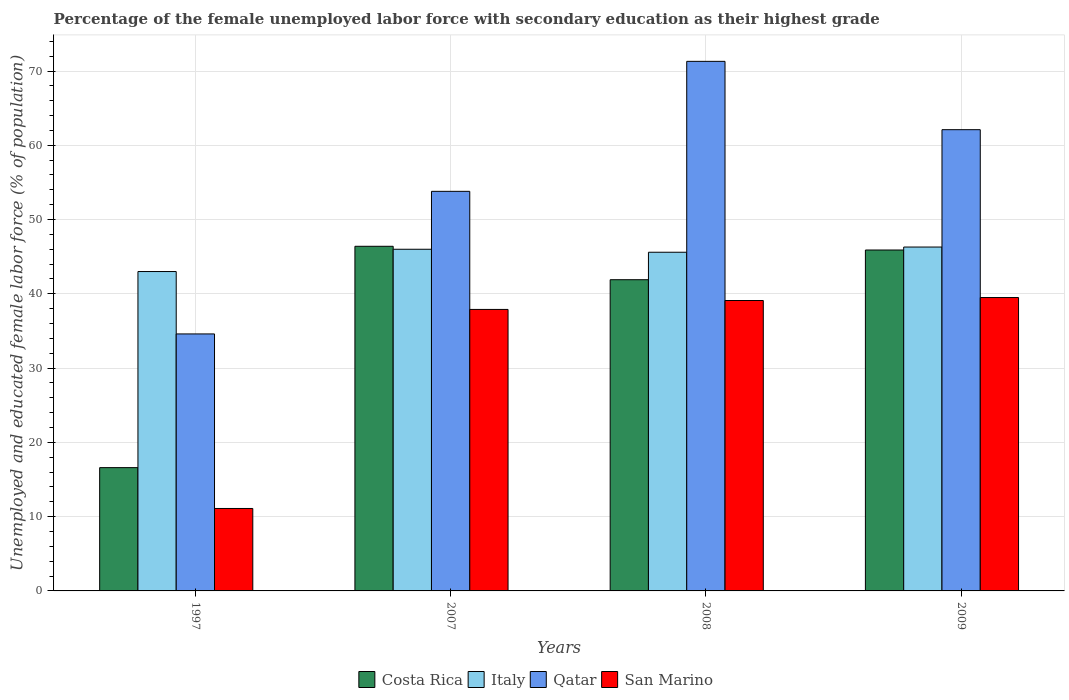How many different coloured bars are there?
Offer a terse response. 4. How many groups of bars are there?
Ensure brevity in your answer.  4. Are the number of bars per tick equal to the number of legend labels?
Offer a very short reply. Yes. How many bars are there on the 1st tick from the left?
Provide a succinct answer. 4. In how many cases, is the number of bars for a given year not equal to the number of legend labels?
Offer a very short reply. 0. What is the percentage of the unemployed female labor force with secondary education in Qatar in 2008?
Your answer should be compact. 71.3. Across all years, what is the maximum percentage of the unemployed female labor force with secondary education in San Marino?
Your answer should be compact. 39.5. Across all years, what is the minimum percentage of the unemployed female labor force with secondary education in Qatar?
Your response must be concise. 34.6. In which year was the percentage of the unemployed female labor force with secondary education in Qatar maximum?
Offer a very short reply. 2008. In which year was the percentage of the unemployed female labor force with secondary education in Italy minimum?
Your answer should be very brief. 1997. What is the total percentage of the unemployed female labor force with secondary education in Costa Rica in the graph?
Give a very brief answer. 150.8. What is the difference between the percentage of the unemployed female labor force with secondary education in Qatar in 2007 and that in 2008?
Provide a succinct answer. -17.5. What is the difference between the percentage of the unemployed female labor force with secondary education in Italy in 2008 and the percentage of the unemployed female labor force with secondary education in Costa Rica in 2009?
Make the answer very short. -0.3. What is the average percentage of the unemployed female labor force with secondary education in San Marino per year?
Keep it short and to the point. 31.9. In the year 1997, what is the difference between the percentage of the unemployed female labor force with secondary education in Italy and percentage of the unemployed female labor force with secondary education in Costa Rica?
Offer a terse response. 26.4. In how many years, is the percentage of the unemployed female labor force with secondary education in Italy greater than 40 %?
Keep it short and to the point. 4. What is the ratio of the percentage of the unemployed female labor force with secondary education in Italy in 2008 to that in 2009?
Provide a short and direct response. 0.98. What is the difference between the highest and the lowest percentage of the unemployed female labor force with secondary education in Italy?
Keep it short and to the point. 3.3. In how many years, is the percentage of the unemployed female labor force with secondary education in Italy greater than the average percentage of the unemployed female labor force with secondary education in Italy taken over all years?
Provide a short and direct response. 3. What does the 4th bar from the left in 2009 represents?
Give a very brief answer. San Marino. What does the 1st bar from the right in 1997 represents?
Your response must be concise. San Marino. Is it the case that in every year, the sum of the percentage of the unemployed female labor force with secondary education in San Marino and percentage of the unemployed female labor force with secondary education in Costa Rica is greater than the percentage of the unemployed female labor force with secondary education in Qatar?
Your answer should be compact. No. How many bars are there?
Provide a short and direct response. 16. How many years are there in the graph?
Give a very brief answer. 4. Are the values on the major ticks of Y-axis written in scientific E-notation?
Provide a succinct answer. No. Does the graph contain grids?
Your answer should be very brief. Yes. Where does the legend appear in the graph?
Your answer should be very brief. Bottom center. How many legend labels are there?
Make the answer very short. 4. How are the legend labels stacked?
Your response must be concise. Horizontal. What is the title of the graph?
Ensure brevity in your answer.  Percentage of the female unemployed labor force with secondary education as their highest grade. Does "OECD members" appear as one of the legend labels in the graph?
Ensure brevity in your answer.  No. What is the label or title of the Y-axis?
Your response must be concise. Unemployed and educated female labor force (% of population). What is the Unemployed and educated female labor force (% of population) in Costa Rica in 1997?
Keep it short and to the point. 16.6. What is the Unemployed and educated female labor force (% of population) in Qatar in 1997?
Ensure brevity in your answer.  34.6. What is the Unemployed and educated female labor force (% of population) in San Marino in 1997?
Your response must be concise. 11.1. What is the Unemployed and educated female labor force (% of population) of Costa Rica in 2007?
Make the answer very short. 46.4. What is the Unemployed and educated female labor force (% of population) in Italy in 2007?
Your answer should be compact. 46. What is the Unemployed and educated female labor force (% of population) in Qatar in 2007?
Your response must be concise. 53.8. What is the Unemployed and educated female labor force (% of population) of San Marino in 2007?
Your response must be concise. 37.9. What is the Unemployed and educated female labor force (% of population) of Costa Rica in 2008?
Offer a very short reply. 41.9. What is the Unemployed and educated female labor force (% of population) in Italy in 2008?
Make the answer very short. 45.6. What is the Unemployed and educated female labor force (% of population) in Qatar in 2008?
Give a very brief answer. 71.3. What is the Unemployed and educated female labor force (% of population) in San Marino in 2008?
Provide a succinct answer. 39.1. What is the Unemployed and educated female labor force (% of population) in Costa Rica in 2009?
Offer a very short reply. 45.9. What is the Unemployed and educated female labor force (% of population) of Italy in 2009?
Provide a succinct answer. 46.3. What is the Unemployed and educated female labor force (% of population) of Qatar in 2009?
Provide a short and direct response. 62.1. What is the Unemployed and educated female labor force (% of population) in San Marino in 2009?
Give a very brief answer. 39.5. Across all years, what is the maximum Unemployed and educated female labor force (% of population) in Costa Rica?
Offer a terse response. 46.4. Across all years, what is the maximum Unemployed and educated female labor force (% of population) in Italy?
Your answer should be compact. 46.3. Across all years, what is the maximum Unemployed and educated female labor force (% of population) of Qatar?
Your answer should be very brief. 71.3. Across all years, what is the maximum Unemployed and educated female labor force (% of population) of San Marino?
Offer a terse response. 39.5. Across all years, what is the minimum Unemployed and educated female labor force (% of population) of Costa Rica?
Offer a terse response. 16.6. Across all years, what is the minimum Unemployed and educated female labor force (% of population) of Italy?
Give a very brief answer. 43. Across all years, what is the minimum Unemployed and educated female labor force (% of population) of Qatar?
Your answer should be very brief. 34.6. Across all years, what is the minimum Unemployed and educated female labor force (% of population) of San Marino?
Keep it short and to the point. 11.1. What is the total Unemployed and educated female labor force (% of population) of Costa Rica in the graph?
Ensure brevity in your answer.  150.8. What is the total Unemployed and educated female labor force (% of population) in Italy in the graph?
Make the answer very short. 180.9. What is the total Unemployed and educated female labor force (% of population) of Qatar in the graph?
Give a very brief answer. 221.8. What is the total Unemployed and educated female labor force (% of population) in San Marino in the graph?
Provide a succinct answer. 127.6. What is the difference between the Unemployed and educated female labor force (% of population) in Costa Rica in 1997 and that in 2007?
Make the answer very short. -29.8. What is the difference between the Unemployed and educated female labor force (% of population) of Italy in 1997 and that in 2007?
Offer a very short reply. -3. What is the difference between the Unemployed and educated female labor force (% of population) of Qatar in 1997 and that in 2007?
Your answer should be compact. -19.2. What is the difference between the Unemployed and educated female labor force (% of population) of San Marino in 1997 and that in 2007?
Your answer should be compact. -26.8. What is the difference between the Unemployed and educated female labor force (% of population) in Costa Rica in 1997 and that in 2008?
Ensure brevity in your answer.  -25.3. What is the difference between the Unemployed and educated female labor force (% of population) in Qatar in 1997 and that in 2008?
Ensure brevity in your answer.  -36.7. What is the difference between the Unemployed and educated female labor force (% of population) in San Marino in 1997 and that in 2008?
Ensure brevity in your answer.  -28. What is the difference between the Unemployed and educated female labor force (% of population) of Costa Rica in 1997 and that in 2009?
Your answer should be very brief. -29.3. What is the difference between the Unemployed and educated female labor force (% of population) in Italy in 1997 and that in 2009?
Your answer should be compact. -3.3. What is the difference between the Unemployed and educated female labor force (% of population) of Qatar in 1997 and that in 2009?
Offer a very short reply. -27.5. What is the difference between the Unemployed and educated female labor force (% of population) of San Marino in 1997 and that in 2009?
Ensure brevity in your answer.  -28.4. What is the difference between the Unemployed and educated female labor force (% of population) in Qatar in 2007 and that in 2008?
Your response must be concise. -17.5. What is the difference between the Unemployed and educated female labor force (% of population) of San Marino in 2007 and that in 2008?
Keep it short and to the point. -1.2. What is the difference between the Unemployed and educated female labor force (% of population) in Costa Rica in 2007 and that in 2009?
Give a very brief answer. 0.5. What is the difference between the Unemployed and educated female labor force (% of population) in Italy in 2007 and that in 2009?
Keep it short and to the point. -0.3. What is the difference between the Unemployed and educated female labor force (% of population) in Qatar in 2007 and that in 2009?
Keep it short and to the point. -8.3. What is the difference between the Unemployed and educated female labor force (% of population) of Qatar in 2008 and that in 2009?
Ensure brevity in your answer.  9.2. What is the difference between the Unemployed and educated female labor force (% of population) in Costa Rica in 1997 and the Unemployed and educated female labor force (% of population) in Italy in 2007?
Make the answer very short. -29.4. What is the difference between the Unemployed and educated female labor force (% of population) of Costa Rica in 1997 and the Unemployed and educated female labor force (% of population) of Qatar in 2007?
Give a very brief answer. -37.2. What is the difference between the Unemployed and educated female labor force (% of population) in Costa Rica in 1997 and the Unemployed and educated female labor force (% of population) in San Marino in 2007?
Your answer should be very brief. -21.3. What is the difference between the Unemployed and educated female labor force (% of population) of Italy in 1997 and the Unemployed and educated female labor force (% of population) of San Marino in 2007?
Offer a very short reply. 5.1. What is the difference between the Unemployed and educated female labor force (% of population) in Costa Rica in 1997 and the Unemployed and educated female labor force (% of population) in Italy in 2008?
Ensure brevity in your answer.  -29. What is the difference between the Unemployed and educated female labor force (% of population) in Costa Rica in 1997 and the Unemployed and educated female labor force (% of population) in Qatar in 2008?
Your answer should be very brief. -54.7. What is the difference between the Unemployed and educated female labor force (% of population) in Costa Rica in 1997 and the Unemployed and educated female labor force (% of population) in San Marino in 2008?
Provide a succinct answer. -22.5. What is the difference between the Unemployed and educated female labor force (% of population) of Italy in 1997 and the Unemployed and educated female labor force (% of population) of Qatar in 2008?
Provide a succinct answer. -28.3. What is the difference between the Unemployed and educated female labor force (% of population) in Italy in 1997 and the Unemployed and educated female labor force (% of population) in San Marino in 2008?
Ensure brevity in your answer.  3.9. What is the difference between the Unemployed and educated female labor force (% of population) of Costa Rica in 1997 and the Unemployed and educated female labor force (% of population) of Italy in 2009?
Offer a terse response. -29.7. What is the difference between the Unemployed and educated female labor force (% of population) of Costa Rica in 1997 and the Unemployed and educated female labor force (% of population) of Qatar in 2009?
Your response must be concise. -45.5. What is the difference between the Unemployed and educated female labor force (% of population) in Costa Rica in 1997 and the Unemployed and educated female labor force (% of population) in San Marino in 2009?
Give a very brief answer. -22.9. What is the difference between the Unemployed and educated female labor force (% of population) of Italy in 1997 and the Unemployed and educated female labor force (% of population) of Qatar in 2009?
Provide a succinct answer. -19.1. What is the difference between the Unemployed and educated female labor force (% of population) in Qatar in 1997 and the Unemployed and educated female labor force (% of population) in San Marino in 2009?
Your answer should be very brief. -4.9. What is the difference between the Unemployed and educated female labor force (% of population) in Costa Rica in 2007 and the Unemployed and educated female labor force (% of population) in Qatar in 2008?
Provide a succinct answer. -24.9. What is the difference between the Unemployed and educated female labor force (% of population) of Italy in 2007 and the Unemployed and educated female labor force (% of population) of Qatar in 2008?
Offer a terse response. -25.3. What is the difference between the Unemployed and educated female labor force (% of population) of Qatar in 2007 and the Unemployed and educated female labor force (% of population) of San Marino in 2008?
Provide a succinct answer. 14.7. What is the difference between the Unemployed and educated female labor force (% of population) in Costa Rica in 2007 and the Unemployed and educated female labor force (% of population) in Italy in 2009?
Offer a very short reply. 0.1. What is the difference between the Unemployed and educated female labor force (% of population) in Costa Rica in 2007 and the Unemployed and educated female labor force (% of population) in Qatar in 2009?
Offer a very short reply. -15.7. What is the difference between the Unemployed and educated female labor force (% of population) in Italy in 2007 and the Unemployed and educated female labor force (% of population) in Qatar in 2009?
Your response must be concise. -16.1. What is the difference between the Unemployed and educated female labor force (% of population) in Italy in 2007 and the Unemployed and educated female labor force (% of population) in San Marino in 2009?
Your response must be concise. 6.5. What is the difference between the Unemployed and educated female labor force (% of population) of Costa Rica in 2008 and the Unemployed and educated female labor force (% of population) of Italy in 2009?
Keep it short and to the point. -4.4. What is the difference between the Unemployed and educated female labor force (% of population) of Costa Rica in 2008 and the Unemployed and educated female labor force (% of population) of Qatar in 2009?
Give a very brief answer. -20.2. What is the difference between the Unemployed and educated female labor force (% of population) of Italy in 2008 and the Unemployed and educated female labor force (% of population) of Qatar in 2009?
Your answer should be compact. -16.5. What is the difference between the Unemployed and educated female labor force (% of population) of Italy in 2008 and the Unemployed and educated female labor force (% of population) of San Marino in 2009?
Your response must be concise. 6.1. What is the difference between the Unemployed and educated female labor force (% of population) of Qatar in 2008 and the Unemployed and educated female labor force (% of population) of San Marino in 2009?
Your answer should be very brief. 31.8. What is the average Unemployed and educated female labor force (% of population) in Costa Rica per year?
Offer a very short reply. 37.7. What is the average Unemployed and educated female labor force (% of population) of Italy per year?
Offer a very short reply. 45.23. What is the average Unemployed and educated female labor force (% of population) of Qatar per year?
Offer a very short reply. 55.45. What is the average Unemployed and educated female labor force (% of population) in San Marino per year?
Your response must be concise. 31.9. In the year 1997, what is the difference between the Unemployed and educated female labor force (% of population) of Costa Rica and Unemployed and educated female labor force (% of population) of Italy?
Provide a succinct answer. -26.4. In the year 1997, what is the difference between the Unemployed and educated female labor force (% of population) of Italy and Unemployed and educated female labor force (% of population) of San Marino?
Your answer should be very brief. 31.9. In the year 1997, what is the difference between the Unemployed and educated female labor force (% of population) of Qatar and Unemployed and educated female labor force (% of population) of San Marino?
Your response must be concise. 23.5. In the year 2007, what is the difference between the Unemployed and educated female labor force (% of population) in Italy and Unemployed and educated female labor force (% of population) in San Marino?
Provide a succinct answer. 8.1. In the year 2007, what is the difference between the Unemployed and educated female labor force (% of population) in Qatar and Unemployed and educated female labor force (% of population) in San Marino?
Your answer should be very brief. 15.9. In the year 2008, what is the difference between the Unemployed and educated female labor force (% of population) in Costa Rica and Unemployed and educated female labor force (% of population) in Italy?
Provide a short and direct response. -3.7. In the year 2008, what is the difference between the Unemployed and educated female labor force (% of population) of Costa Rica and Unemployed and educated female labor force (% of population) of Qatar?
Your response must be concise. -29.4. In the year 2008, what is the difference between the Unemployed and educated female labor force (% of population) in Costa Rica and Unemployed and educated female labor force (% of population) in San Marino?
Offer a very short reply. 2.8. In the year 2008, what is the difference between the Unemployed and educated female labor force (% of population) in Italy and Unemployed and educated female labor force (% of population) in Qatar?
Provide a short and direct response. -25.7. In the year 2008, what is the difference between the Unemployed and educated female labor force (% of population) of Italy and Unemployed and educated female labor force (% of population) of San Marino?
Provide a succinct answer. 6.5. In the year 2008, what is the difference between the Unemployed and educated female labor force (% of population) of Qatar and Unemployed and educated female labor force (% of population) of San Marino?
Keep it short and to the point. 32.2. In the year 2009, what is the difference between the Unemployed and educated female labor force (% of population) of Costa Rica and Unemployed and educated female labor force (% of population) of Italy?
Offer a very short reply. -0.4. In the year 2009, what is the difference between the Unemployed and educated female labor force (% of population) of Costa Rica and Unemployed and educated female labor force (% of population) of Qatar?
Ensure brevity in your answer.  -16.2. In the year 2009, what is the difference between the Unemployed and educated female labor force (% of population) of Costa Rica and Unemployed and educated female labor force (% of population) of San Marino?
Give a very brief answer. 6.4. In the year 2009, what is the difference between the Unemployed and educated female labor force (% of population) in Italy and Unemployed and educated female labor force (% of population) in Qatar?
Offer a terse response. -15.8. In the year 2009, what is the difference between the Unemployed and educated female labor force (% of population) of Italy and Unemployed and educated female labor force (% of population) of San Marino?
Provide a succinct answer. 6.8. In the year 2009, what is the difference between the Unemployed and educated female labor force (% of population) in Qatar and Unemployed and educated female labor force (% of population) in San Marino?
Your answer should be very brief. 22.6. What is the ratio of the Unemployed and educated female labor force (% of population) in Costa Rica in 1997 to that in 2007?
Offer a very short reply. 0.36. What is the ratio of the Unemployed and educated female labor force (% of population) in Italy in 1997 to that in 2007?
Keep it short and to the point. 0.93. What is the ratio of the Unemployed and educated female labor force (% of population) in Qatar in 1997 to that in 2007?
Make the answer very short. 0.64. What is the ratio of the Unemployed and educated female labor force (% of population) of San Marino in 1997 to that in 2007?
Keep it short and to the point. 0.29. What is the ratio of the Unemployed and educated female labor force (% of population) of Costa Rica in 1997 to that in 2008?
Your answer should be very brief. 0.4. What is the ratio of the Unemployed and educated female labor force (% of population) in Italy in 1997 to that in 2008?
Ensure brevity in your answer.  0.94. What is the ratio of the Unemployed and educated female labor force (% of population) of Qatar in 1997 to that in 2008?
Offer a terse response. 0.49. What is the ratio of the Unemployed and educated female labor force (% of population) in San Marino in 1997 to that in 2008?
Keep it short and to the point. 0.28. What is the ratio of the Unemployed and educated female labor force (% of population) of Costa Rica in 1997 to that in 2009?
Provide a succinct answer. 0.36. What is the ratio of the Unemployed and educated female labor force (% of population) of Italy in 1997 to that in 2009?
Provide a succinct answer. 0.93. What is the ratio of the Unemployed and educated female labor force (% of population) of Qatar in 1997 to that in 2009?
Ensure brevity in your answer.  0.56. What is the ratio of the Unemployed and educated female labor force (% of population) of San Marino in 1997 to that in 2009?
Offer a terse response. 0.28. What is the ratio of the Unemployed and educated female labor force (% of population) of Costa Rica in 2007 to that in 2008?
Offer a very short reply. 1.11. What is the ratio of the Unemployed and educated female labor force (% of population) in Italy in 2007 to that in 2008?
Give a very brief answer. 1.01. What is the ratio of the Unemployed and educated female labor force (% of population) of Qatar in 2007 to that in 2008?
Provide a short and direct response. 0.75. What is the ratio of the Unemployed and educated female labor force (% of population) of San Marino in 2007 to that in 2008?
Your answer should be very brief. 0.97. What is the ratio of the Unemployed and educated female labor force (% of population) of Costa Rica in 2007 to that in 2009?
Keep it short and to the point. 1.01. What is the ratio of the Unemployed and educated female labor force (% of population) of Qatar in 2007 to that in 2009?
Make the answer very short. 0.87. What is the ratio of the Unemployed and educated female labor force (% of population) in San Marino in 2007 to that in 2009?
Offer a terse response. 0.96. What is the ratio of the Unemployed and educated female labor force (% of population) in Costa Rica in 2008 to that in 2009?
Your answer should be compact. 0.91. What is the ratio of the Unemployed and educated female labor force (% of population) in Italy in 2008 to that in 2009?
Your answer should be very brief. 0.98. What is the ratio of the Unemployed and educated female labor force (% of population) in Qatar in 2008 to that in 2009?
Ensure brevity in your answer.  1.15. What is the ratio of the Unemployed and educated female labor force (% of population) in San Marino in 2008 to that in 2009?
Offer a very short reply. 0.99. What is the difference between the highest and the second highest Unemployed and educated female labor force (% of population) in Costa Rica?
Your answer should be very brief. 0.5. What is the difference between the highest and the second highest Unemployed and educated female labor force (% of population) of Qatar?
Make the answer very short. 9.2. What is the difference between the highest and the second highest Unemployed and educated female labor force (% of population) in San Marino?
Ensure brevity in your answer.  0.4. What is the difference between the highest and the lowest Unemployed and educated female labor force (% of population) of Costa Rica?
Make the answer very short. 29.8. What is the difference between the highest and the lowest Unemployed and educated female labor force (% of population) in Italy?
Offer a very short reply. 3.3. What is the difference between the highest and the lowest Unemployed and educated female labor force (% of population) of Qatar?
Make the answer very short. 36.7. What is the difference between the highest and the lowest Unemployed and educated female labor force (% of population) of San Marino?
Ensure brevity in your answer.  28.4. 